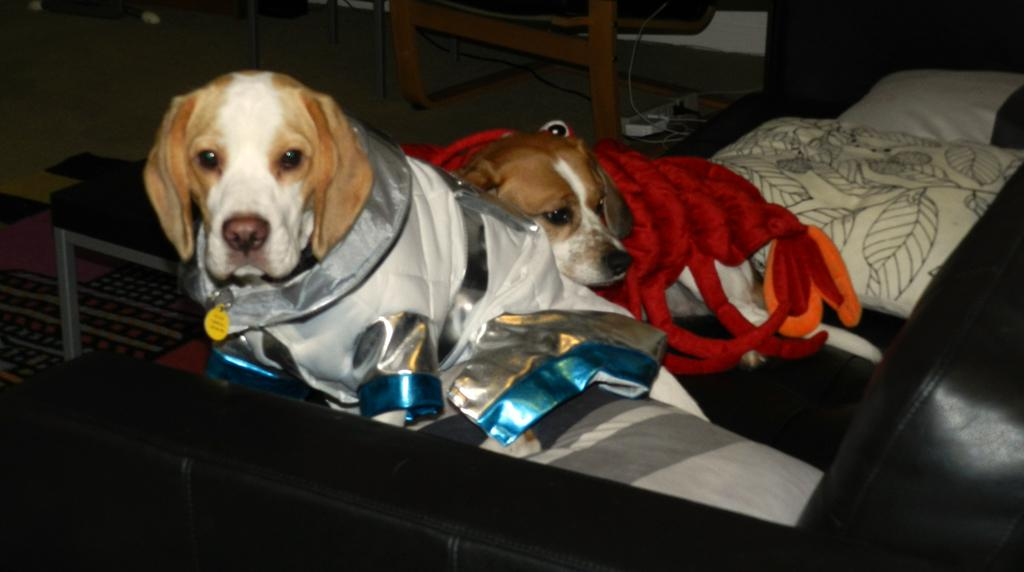How many dogs are present in the image? There are two dogs in the image. What type of furniture is at the bottom of the image? There is a sofa at the bottom of the image. What is located in the front of the image? There is a wooden table in the front of the image. What type of surface is visible at the bottom of the image? There is a floor visible at the bottom of the image. What type of clover is growing on the floor in the image? There is no clover present in the image; the floor is visible but does not have any plants growing on it. 